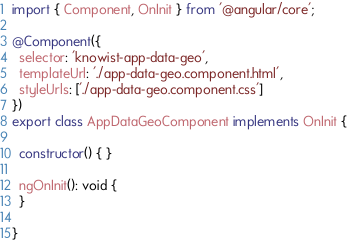<code> <loc_0><loc_0><loc_500><loc_500><_TypeScript_>import { Component, OnInit } from '@angular/core';

@Component({
  selector: 'knowist-app-data-geo',
  templateUrl: './app-data-geo.component.html',
  styleUrls: ['./app-data-geo.component.css']
})
export class AppDataGeoComponent implements OnInit {

  constructor() { }

  ngOnInit(): void {
  }

}
</code> 